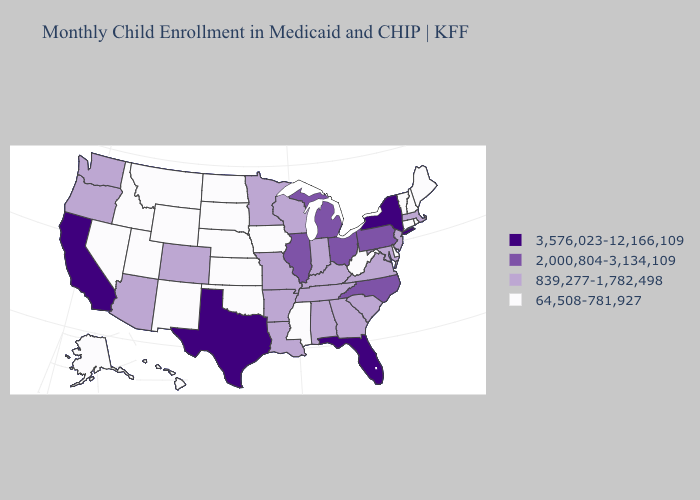What is the highest value in the USA?
Give a very brief answer. 3,576,023-12,166,109. What is the value of Missouri?
Concise answer only. 839,277-1,782,498. Does Arkansas have a lower value than Montana?
Short answer required. No. Does California have the highest value in the USA?
Give a very brief answer. Yes. Name the states that have a value in the range 3,576,023-12,166,109?
Write a very short answer. California, Florida, New York, Texas. Does North Dakota have the lowest value in the USA?
Short answer required. Yes. What is the value of Nebraska?
Write a very short answer. 64,508-781,927. What is the value of Wyoming?
Answer briefly. 64,508-781,927. Which states have the highest value in the USA?
Short answer required. California, Florida, New York, Texas. What is the value of Massachusetts?
Keep it brief. 839,277-1,782,498. How many symbols are there in the legend?
Concise answer only. 4. What is the value of Mississippi?
Keep it brief. 64,508-781,927. What is the highest value in the USA?
Keep it brief. 3,576,023-12,166,109. Which states hav the highest value in the MidWest?
Answer briefly. Illinois, Michigan, Ohio. Which states hav the highest value in the West?
Keep it brief. California. 